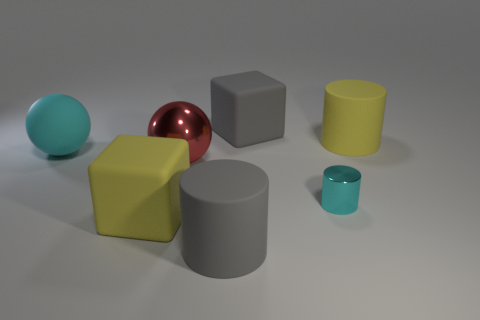How do the textures of the objects compare? In the image, each object seems to have a uniformly smooth and reflective texture. However, the red sphere stands out because of its highly reflective, shiny surface, which suggests it might be metallic, while the other objects appear to be made of matte or slightly less reflective materials like rubber or plastic. 